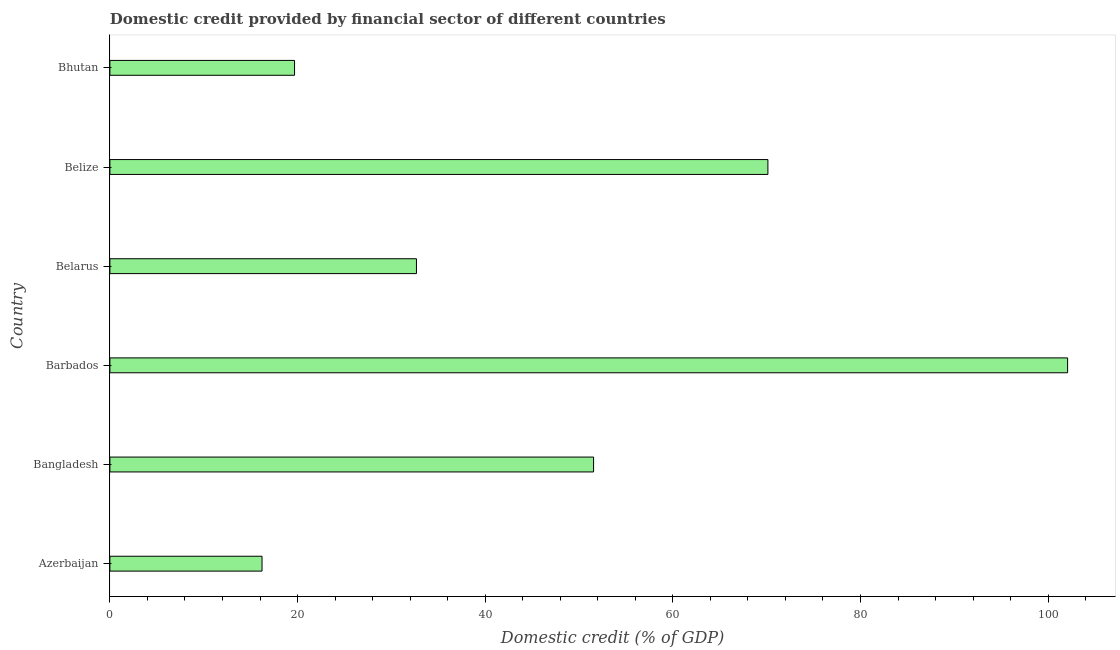Does the graph contain grids?
Offer a terse response. No. What is the title of the graph?
Offer a very short reply. Domestic credit provided by financial sector of different countries. What is the label or title of the X-axis?
Provide a short and direct response. Domestic credit (% of GDP). What is the label or title of the Y-axis?
Your answer should be compact. Country. What is the domestic credit provided by financial sector in Azerbaijan?
Ensure brevity in your answer.  16.22. Across all countries, what is the maximum domestic credit provided by financial sector?
Keep it short and to the point. 102.07. Across all countries, what is the minimum domestic credit provided by financial sector?
Provide a succinct answer. 16.22. In which country was the domestic credit provided by financial sector maximum?
Offer a terse response. Barbados. In which country was the domestic credit provided by financial sector minimum?
Offer a terse response. Azerbaijan. What is the sum of the domestic credit provided by financial sector?
Keep it short and to the point. 292.33. What is the difference between the domestic credit provided by financial sector in Belize and Bhutan?
Your response must be concise. 50.45. What is the average domestic credit provided by financial sector per country?
Provide a short and direct response. 48.72. What is the median domestic credit provided by financial sector?
Your answer should be compact. 42.11. What is the ratio of the domestic credit provided by financial sector in Azerbaijan to that in Belarus?
Keep it short and to the point. 0.5. Is the domestic credit provided by financial sector in Belarus less than that in Bhutan?
Give a very brief answer. No. What is the difference between the highest and the second highest domestic credit provided by financial sector?
Make the answer very short. 31.94. Is the sum of the domestic credit provided by financial sector in Belize and Bhutan greater than the maximum domestic credit provided by financial sector across all countries?
Offer a terse response. No. What is the difference between the highest and the lowest domestic credit provided by financial sector?
Ensure brevity in your answer.  85.86. Are the values on the major ticks of X-axis written in scientific E-notation?
Your answer should be very brief. No. What is the Domestic credit (% of GDP) in Azerbaijan?
Provide a succinct answer. 16.22. What is the Domestic credit (% of GDP) in Bangladesh?
Keep it short and to the point. 51.55. What is the Domestic credit (% of GDP) in Barbados?
Give a very brief answer. 102.07. What is the Domestic credit (% of GDP) in Belarus?
Offer a terse response. 32.67. What is the Domestic credit (% of GDP) in Belize?
Keep it short and to the point. 70.13. What is the Domestic credit (% of GDP) in Bhutan?
Your answer should be very brief. 19.68. What is the difference between the Domestic credit (% of GDP) in Azerbaijan and Bangladesh?
Give a very brief answer. -35.34. What is the difference between the Domestic credit (% of GDP) in Azerbaijan and Barbados?
Offer a very short reply. -85.86. What is the difference between the Domestic credit (% of GDP) in Azerbaijan and Belarus?
Provide a succinct answer. -16.46. What is the difference between the Domestic credit (% of GDP) in Azerbaijan and Belize?
Offer a very short reply. -53.92. What is the difference between the Domestic credit (% of GDP) in Azerbaijan and Bhutan?
Your answer should be very brief. -3.47. What is the difference between the Domestic credit (% of GDP) in Bangladesh and Barbados?
Offer a terse response. -50.52. What is the difference between the Domestic credit (% of GDP) in Bangladesh and Belarus?
Provide a short and direct response. 18.88. What is the difference between the Domestic credit (% of GDP) in Bangladesh and Belize?
Provide a succinct answer. -18.58. What is the difference between the Domestic credit (% of GDP) in Bangladesh and Bhutan?
Keep it short and to the point. 31.87. What is the difference between the Domestic credit (% of GDP) in Barbados and Belarus?
Give a very brief answer. 69.4. What is the difference between the Domestic credit (% of GDP) in Barbados and Belize?
Provide a succinct answer. 31.94. What is the difference between the Domestic credit (% of GDP) in Barbados and Bhutan?
Provide a succinct answer. 82.39. What is the difference between the Domestic credit (% of GDP) in Belarus and Belize?
Keep it short and to the point. -37.46. What is the difference between the Domestic credit (% of GDP) in Belarus and Bhutan?
Your answer should be compact. 12.99. What is the difference between the Domestic credit (% of GDP) in Belize and Bhutan?
Give a very brief answer. 50.45. What is the ratio of the Domestic credit (% of GDP) in Azerbaijan to that in Bangladesh?
Make the answer very short. 0.32. What is the ratio of the Domestic credit (% of GDP) in Azerbaijan to that in Barbados?
Provide a short and direct response. 0.16. What is the ratio of the Domestic credit (% of GDP) in Azerbaijan to that in Belarus?
Give a very brief answer. 0.5. What is the ratio of the Domestic credit (% of GDP) in Azerbaijan to that in Belize?
Provide a succinct answer. 0.23. What is the ratio of the Domestic credit (% of GDP) in Azerbaijan to that in Bhutan?
Make the answer very short. 0.82. What is the ratio of the Domestic credit (% of GDP) in Bangladesh to that in Barbados?
Keep it short and to the point. 0.51. What is the ratio of the Domestic credit (% of GDP) in Bangladesh to that in Belarus?
Offer a very short reply. 1.58. What is the ratio of the Domestic credit (% of GDP) in Bangladesh to that in Belize?
Keep it short and to the point. 0.73. What is the ratio of the Domestic credit (% of GDP) in Bangladesh to that in Bhutan?
Offer a terse response. 2.62. What is the ratio of the Domestic credit (% of GDP) in Barbados to that in Belarus?
Give a very brief answer. 3.12. What is the ratio of the Domestic credit (% of GDP) in Barbados to that in Belize?
Make the answer very short. 1.46. What is the ratio of the Domestic credit (% of GDP) in Barbados to that in Bhutan?
Offer a very short reply. 5.19. What is the ratio of the Domestic credit (% of GDP) in Belarus to that in Belize?
Provide a succinct answer. 0.47. What is the ratio of the Domestic credit (% of GDP) in Belarus to that in Bhutan?
Offer a very short reply. 1.66. What is the ratio of the Domestic credit (% of GDP) in Belize to that in Bhutan?
Make the answer very short. 3.56. 